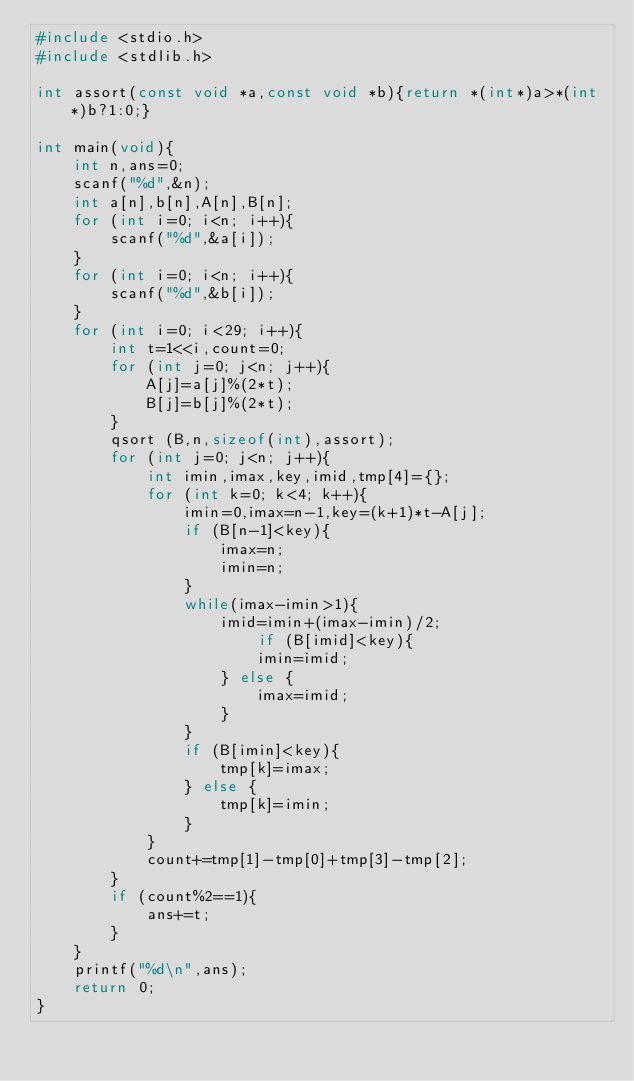<code> <loc_0><loc_0><loc_500><loc_500><_C_>#include <stdio.h>
#include <stdlib.h>

int assort(const void *a,const void *b){return *(int*)a>*(int*)b?1:0;}

int main(void){
    int n,ans=0;
    scanf("%d",&n);
    int a[n],b[n],A[n],B[n];
    for (int i=0; i<n; i++){
        scanf("%d",&a[i]);
    }
    for (int i=0; i<n; i++){
        scanf("%d",&b[i]);
    }
    for (int i=0; i<29; i++){
        int t=1<<i,count=0;
        for (int j=0; j<n; j++){
            A[j]=a[j]%(2*t);
            B[j]=b[j]%(2*t);
        }
        qsort (B,n,sizeof(int),assort);
        for (int j=0; j<n; j++){
            int imin,imax,key,imid,tmp[4]={};
            for (int k=0; k<4; k++){
                imin=0,imax=n-1,key=(k+1)*t-A[j];
                if (B[n-1]<key){
                    imax=n;
                    imin=n;
                }
                while(imax-imin>1){
                    imid=imin+(imax-imin)/2;
                        if (B[imid]<key){
                        imin=imid;
                    } else {
                        imax=imid;
                    }   
                }
                if (B[imin]<key){
                    tmp[k]=imax;
                } else {
                    tmp[k]=imin;
                }
            }
            count+=tmp[1]-tmp[0]+tmp[3]-tmp[2];
        }
        if (count%2==1){
            ans+=t;
        }
    }
    printf("%d\n",ans);
    return 0;
}</code> 